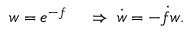<formula> <loc_0><loc_0><loc_500><loc_500>\begin{array} { r l } { w = e ^ { - f } \, } & \Rightarrow \, \dot { w } = - \dot { f } w . } \end{array}</formula> 